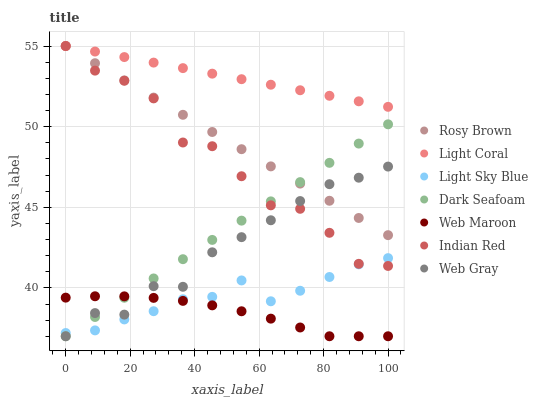Does Web Maroon have the minimum area under the curve?
Answer yes or no. Yes. Does Light Coral have the maximum area under the curve?
Answer yes or no. Yes. Does Rosy Brown have the minimum area under the curve?
Answer yes or no. No. Does Rosy Brown have the maximum area under the curve?
Answer yes or no. No. Is Rosy Brown the smoothest?
Answer yes or no. Yes. Is Indian Red the roughest?
Answer yes or no. Yes. Is Web Maroon the smoothest?
Answer yes or no. No. Is Web Maroon the roughest?
Answer yes or no. No. Does Web Gray have the lowest value?
Answer yes or no. Yes. Does Rosy Brown have the lowest value?
Answer yes or no. No. Does Indian Red have the highest value?
Answer yes or no. Yes. Does Web Maroon have the highest value?
Answer yes or no. No. Is Web Gray less than Light Coral?
Answer yes or no. Yes. Is Light Coral greater than Dark Seafoam?
Answer yes or no. Yes. Does Dark Seafoam intersect Rosy Brown?
Answer yes or no. Yes. Is Dark Seafoam less than Rosy Brown?
Answer yes or no. No. Is Dark Seafoam greater than Rosy Brown?
Answer yes or no. No. Does Web Gray intersect Light Coral?
Answer yes or no. No. 